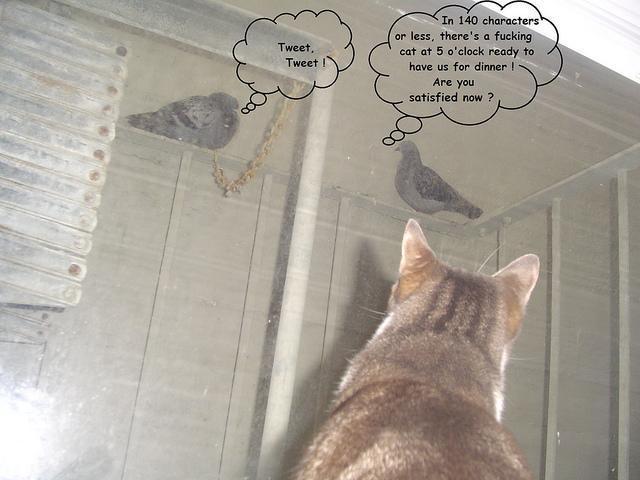How many birds does the cat see?
Give a very brief answer. 2. How many birds are there?
Give a very brief answer. 2. 